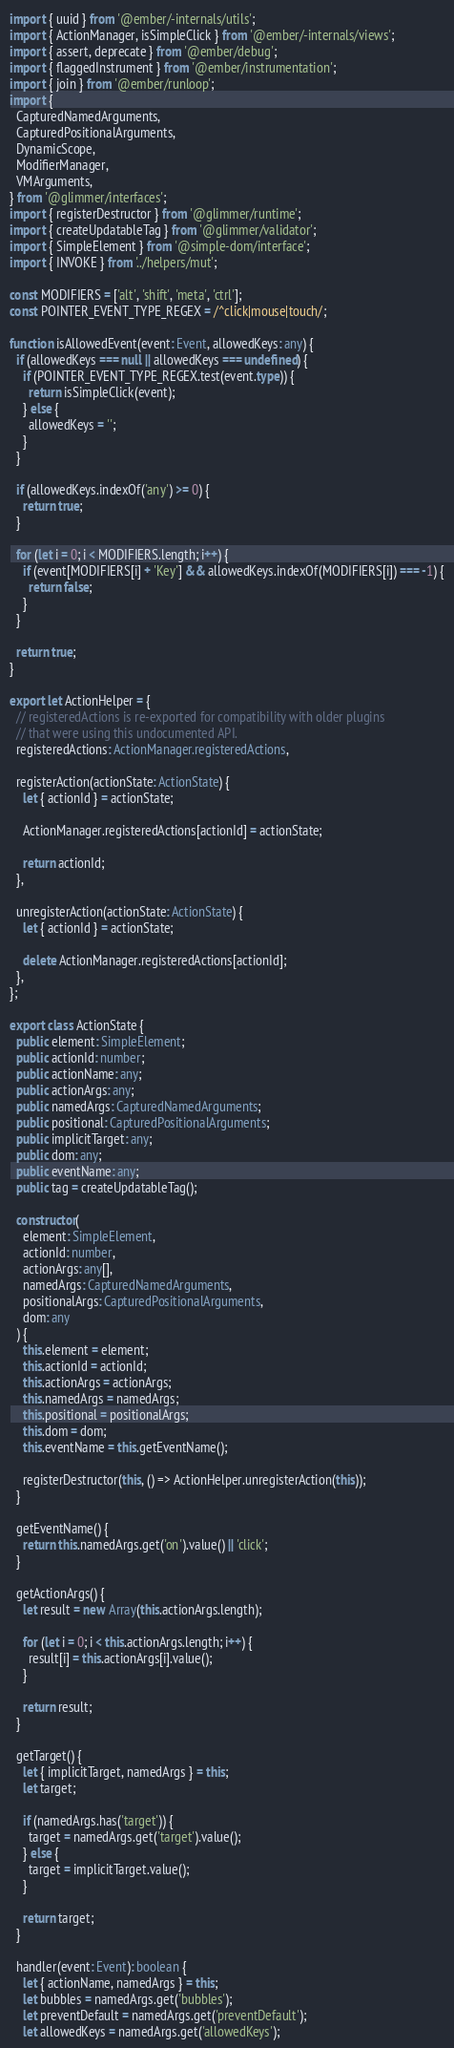<code> <loc_0><loc_0><loc_500><loc_500><_TypeScript_>import { uuid } from '@ember/-internals/utils';
import { ActionManager, isSimpleClick } from '@ember/-internals/views';
import { assert, deprecate } from '@ember/debug';
import { flaggedInstrument } from '@ember/instrumentation';
import { join } from '@ember/runloop';
import {
  CapturedNamedArguments,
  CapturedPositionalArguments,
  DynamicScope,
  ModifierManager,
  VMArguments,
} from '@glimmer/interfaces';
import { registerDestructor } from '@glimmer/runtime';
import { createUpdatableTag } from '@glimmer/validator';
import { SimpleElement } from '@simple-dom/interface';
import { INVOKE } from '../helpers/mut';

const MODIFIERS = ['alt', 'shift', 'meta', 'ctrl'];
const POINTER_EVENT_TYPE_REGEX = /^click|mouse|touch/;

function isAllowedEvent(event: Event, allowedKeys: any) {
  if (allowedKeys === null || allowedKeys === undefined) {
    if (POINTER_EVENT_TYPE_REGEX.test(event.type)) {
      return isSimpleClick(event);
    } else {
      allowedKeys = '';
    }
  }

  if (allowedKeys.indexOf('any') >= 0) {
    return true;
  }

  for (let i = 0; i < MODIFIERS.length; i++) {
    if (event[MODIFIERS[i] + 'Key'] && allowedKeys.indexOf(MODIFIERS[i]) === -1) {
      return false;
    }
  }

  return true;
}

export let ActionHelper = {
  // registeredActions is re-exported for compatibility with older plugins
  // that were using this undocumented API.
  registeredActions: ActionManager.registeredActions,

  registerAction(actionState: ActionState) {
    let { actionId } = actionState;

    ActionManager.registeredActions[actionId] = actionState;

    return actionId;
  },

  unregisterAction(actionState: ActionState) {
    let { actionId } = actionState;

    delete ActionManager.registeredActions[actionId];
  },
};

export class ActionState {
  public element: SimpleElement;
  public actionId: number;
  public actionName: any;
  public actionArgs: any;
  public namedArgs: CapturedNamedArguments;
  public positional: CapturedPositionalArguments;
  public implicitTarget: any;
  public dom: any;
  public eventName: any;
  public tag = createUpdatableTag();

  constructor(
    element: SimpleElement,
    actionId: number,
    actionArgs: any[],
    namedArgs: CapturedNamedArguments,
    positionalArgs: CapturedPositionalArguments,
    dom: any
  ) {
    this.element = element;
    this.actionId = actionId;
    this.actionArgs = actionArgs;
    this.namedArgs = namedArgs;
    this.positional = positionalArgs;
    this.dom = dom;
    this.eventName = this.getEventName();

    registerDestructor(this, () => ActionHelper.unregisterAction(this));
  }

  getEventName() {
    return this.namedArgs.get('on').value() || 'click';
  }

  getActionArgs() {
    let result = new Array(this.actionArgs.length);

    for (let i = 0; i < this.actionArgs.length; i++) {
      result[i] = this.actionArgs[i].value();
    }

    return result;
  }

  getTarget() {
    let { implicitTarget, namedArgs } = this;
    let target;

    if (namedArgs.has('target')) {
      target = namedArgs.get('target').value();
    } else {
      target = implicitTarget.value();
    }

    return target;
  }

  handler(event: Event): boolean {
    let { actionName, namedArgs } = this;
    let bubbles = namedArgs.get('bubbles');
    let preventDefault = namedArgs.get('preventDefault');
    let allowedKeys = namedArgs.get('allowedKeys');</code> 